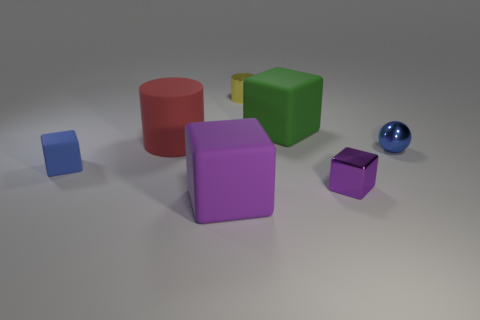Add 1 small rubber things. How many objects exist? 8 Subtract all cyan cylinders. How many purple cubes are left? 2 Subtract all large green matte blocks. How many blocks are left? 3 Subtract 1 blocks. How many blocks are left? 3 Subtract all blue cubes. How many cubes are left? 3 Subtract 1 green blocks. How many objects are left? 6 Subtract all cylinders. How many objects are left? 5 Subtract all gray spheres. Subtract all cyan blocks. How many spheres are left? 1 Subtract all gray shiny objects. Subtract all tiny yellow cylinders. How many objects are left? 6 Add 6 green rubber cubes. How many green rubber cubes are left? 7 